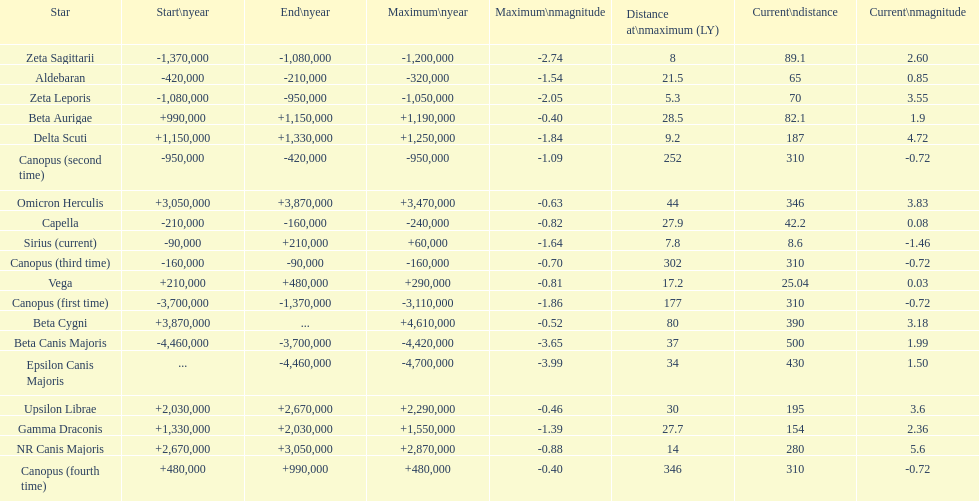What is the only star with a distance at maximum of 80? Beta Cygni. 